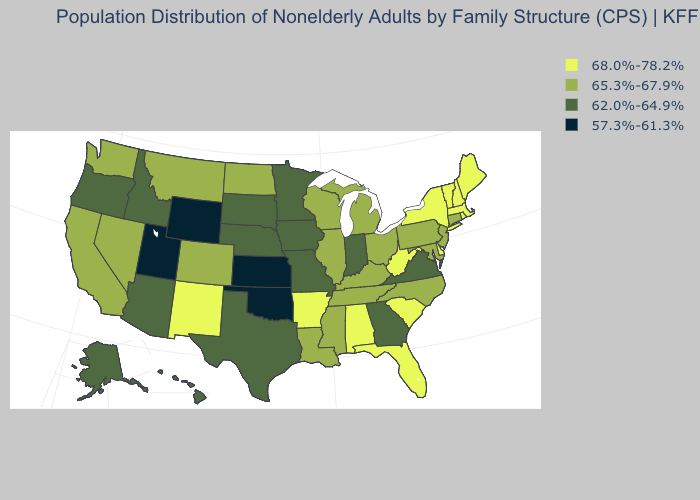What is the value of Vermont?
Write a very short answer. 68.0%-78.2%. Which states have the highest value in the USA?
Concise answer only. Alabama, Arkansas, Delaware, Florida, Maine, Massachusetts, New Hampshire, New Mexico, New York, Rhode Island, South Carolina, Vermont, West Virginia. Does Alaska have the lowest value in the West?
Keep it brief. No. What is the value of Rhode Island?
Short answer required. 68.0%-78.2%. Among the states that border Oregon , which have the highest value?
Keep it brief. California, Nevada, Washington. What is the value of Texas?
Concise answer only. 62.0%-64.9%. What is the highest value in the USA?
Give a very brief answer. 68.0%-78.2%. What is the value of New York?
Concise answer only. 68.0%-78.2%. What is the lowest value in states that border Delaware?
Short answer required. 65.3%-67.9%. Name the states that have a value in the range 57.3%-61.3%?
Give a very brief answer. Kansas, Oklahoma, Utah, Wyoming. What is the value of South Carolina?
Be succinct. 68.0%-78.2%. Is the legend a continuous bar?
Concise answer only. No. What is the lowest value in the USA?
Give a very brief answer. 57.3%-61.3%. Name the states that have a value in the range 65.3%-67.9%?
Write a very short answer. California, Colorado, Connecticut, Illinois, Kentucky, Louisiana, Maryland, Michigan, Mississippi, Montana, Nevada, New Jersey, North Carolina, North Dakota, Ohio, Pennsylvania, Tennessee, Washington, Wisconsin. Name the states that have a value in the range 62.0%-64.9%?
Concise answer only. Alaska, Arizona, Georgia, Hawaii, Idaho, Indiana, Iowa, Minnesota, Missouri, Nebraska, Oregon, South Dakota, Texas, Virginia. 